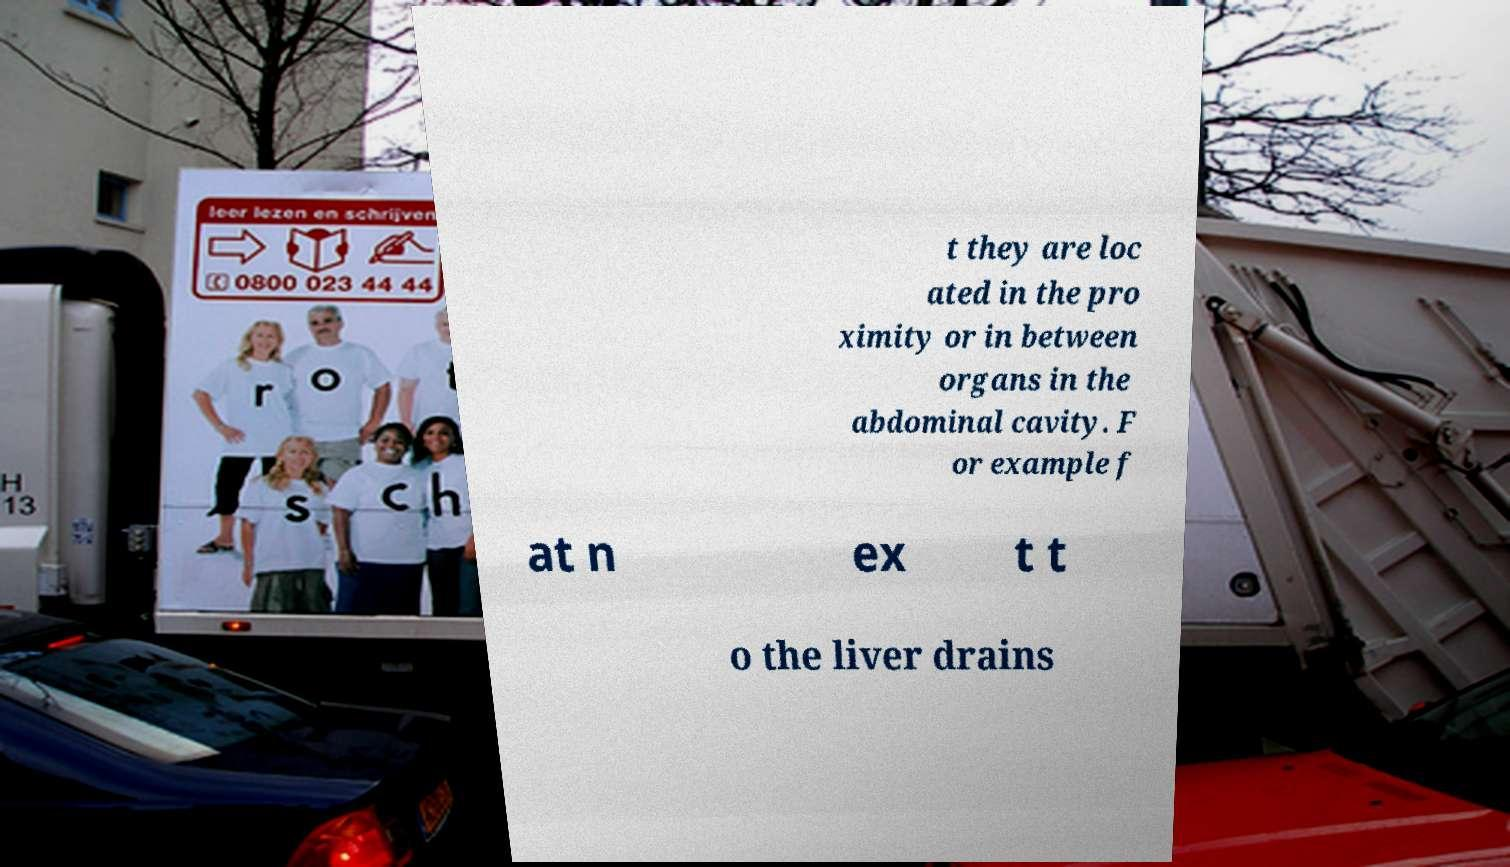Could you extract and type out the text from this image? t they are loc ated in the pro ximity or in between organs in the abdominal cavity. F or example f at n ex t t o the liver drains 